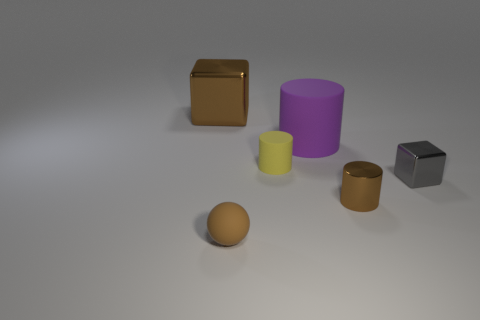What size is the brown ball?
Your answer should be compact. Small. Does the object that is on the left side of the brown rubber object have the same material as the small gray cube?
Offer a terse response. Yes. The metal object that is the same shape as the yellow matte object is what color?
Give a very brief answer. Brown. There is a metallic cube that is in front of the big brown block; does it have the same color as the small sphere?
Offer a very short reply. No. Are there any brown objects on the right side of the yellow cylinder?
Offer a very short reply. Yes. The thing that is both behind the small brown cylinder and on the right side of the purple rubber cylinder is what color?
Provide a short and direct response. Gray. What shape is the shiny thing that is the same color as the tiny metal cylinder?
Your answer should be compact. Cube. There is a rubber object in front of the metallic cube in front of the large brown shiny block; what size is it?
Give a very brief answer. Small. What number of cylinders are big matte objects or matte objects?
Your answer should be very brief. 2. What is the color of the metallic cylinder that is the same size as the brown rubber object?
Your response must be concise. Brown. 